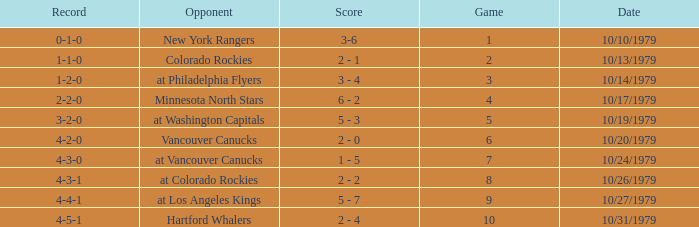Who is the opponent before game 5 with a 0-1-0 record? New York Rangers. 